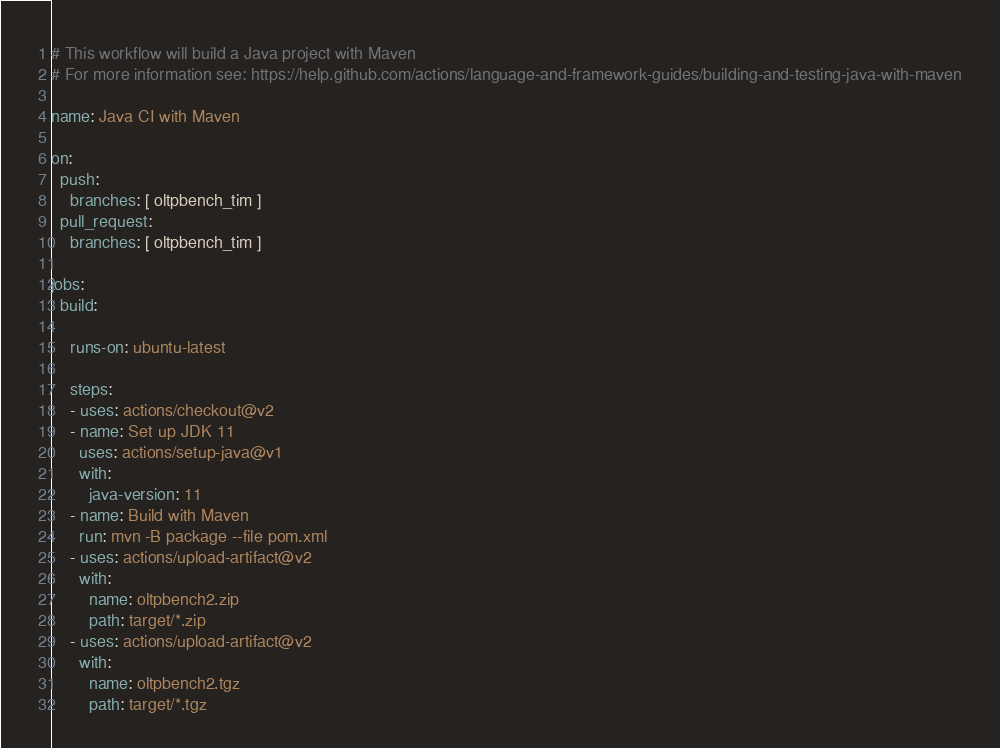Convert code to text. <code><loc_0><loc_0><loc_500><loc_500><_YAML_># This workflow will build a Java project with Maven
# For more information see: https://help.github.com/actions/language-and-framework-guides/building-and-testing-java-with-maven

name: Java CI with Maven

on:
  push:
    branches: [ oltpbench_tim ]
  pull_request:
    branches: [ oltpbench_tim ]

jobs:
  build:

    runs-on: ubuntu-latest

    steps:
    - uses: actions/checkout@v2
    - name: Set up JDK 11
      uses: actions/setup-java@v1
      with:
        java-version: 11
    - name: Build with Maven
      run: mvn -B package --file pom.xml
    - uses: actions/upload-artifact@v2
      with:
        name: oltpbench2.zip
        path: target/*.zip
    - uses: actions/upload-artifact@v2
      with:
        name: oltpbench2.tgz
        path: target/*.tgz</code> 